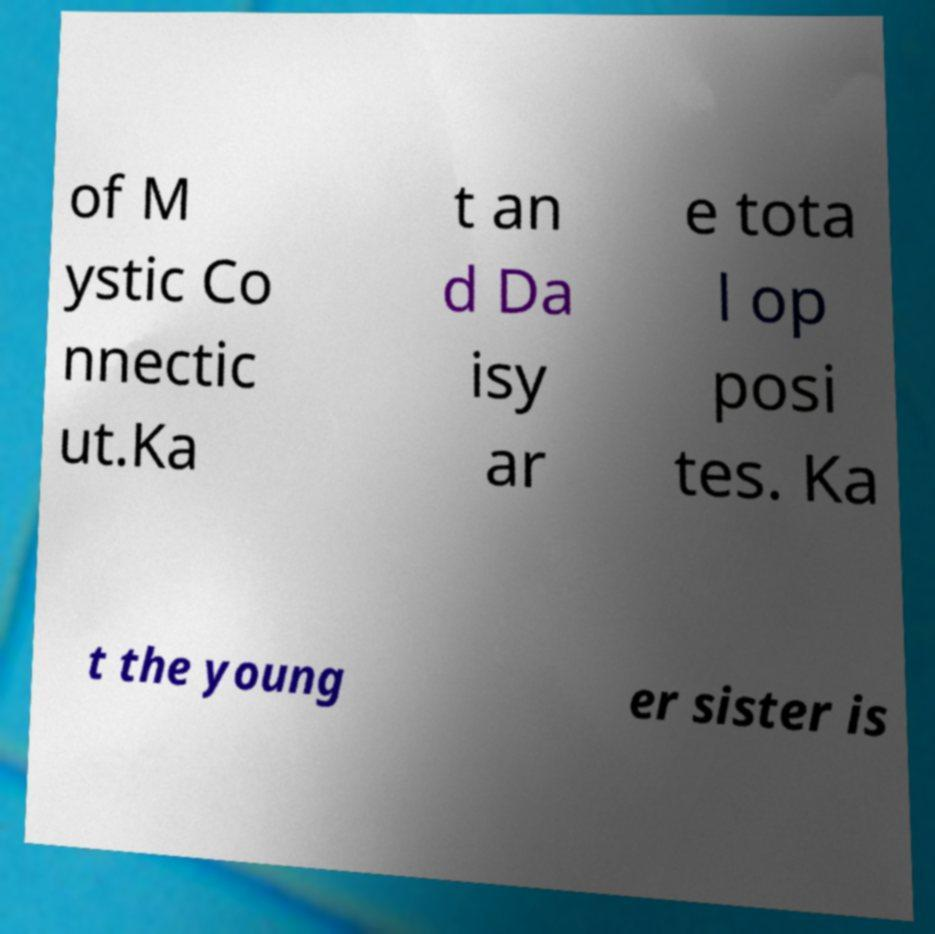Can you accurately transcribe the text from the provided image for me? of M ystic Co nnectic ut.Ka t an d Da isy ar e tota l op posi tes. Ka t the young er sister is 